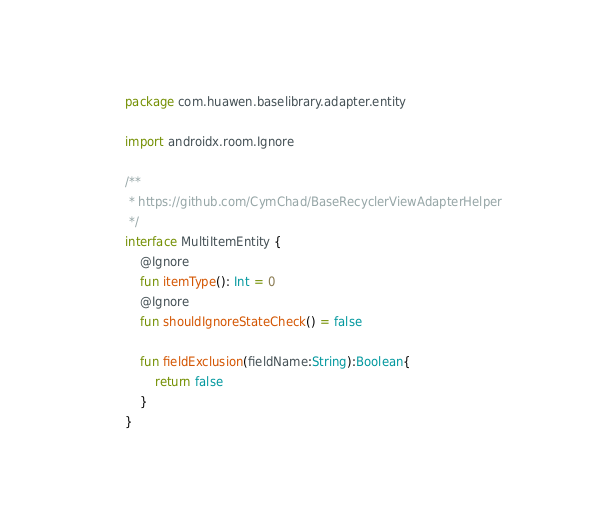Convert code to text. <code><loc_0><loc_0><loc_500><loc_500><_Kotlin_>package com.huawen.baselibrary.adapter.entity

import androidx.room.Ignore

/**
 * https://github.com/CymChad/BaseRecyclerViewAdapterHelper
 */
interface MultiItemEntity {
    @Ignore
    fun itemType(): Int = 0
    @Ignore
    fun shouldIgnoreStateCheck() = false

    fun fieldExclusion(fieldName:String):Boolean{
        return false
    }
}
</code> 